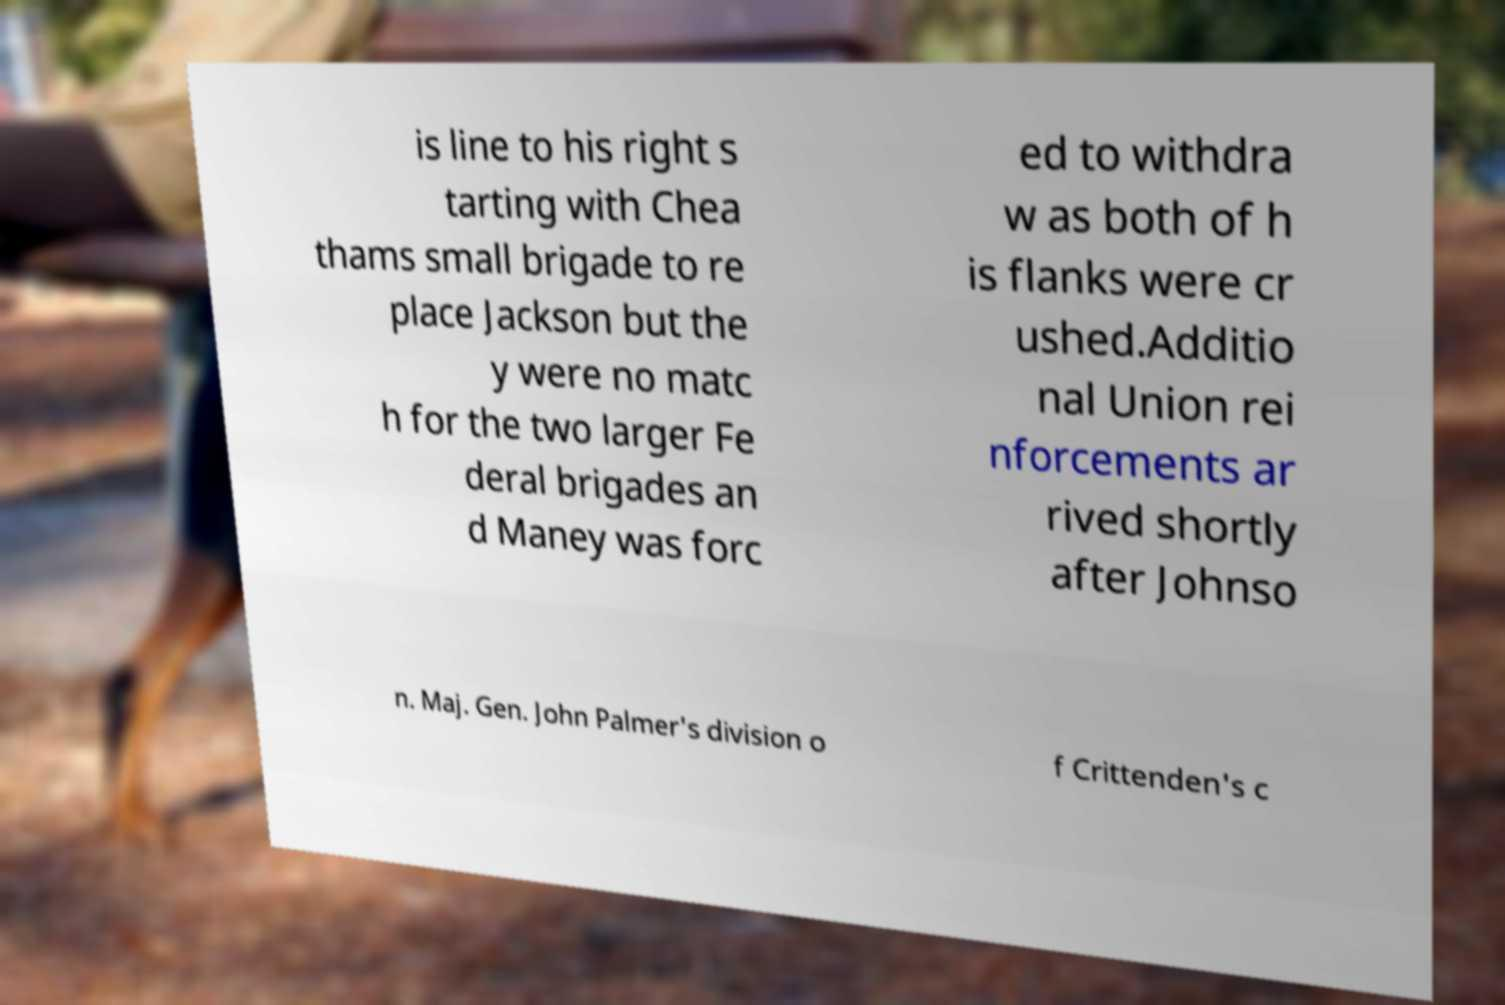Could you assist in decoding the text presented in this image and type it out clearly? is line to his right s tarting with Chea thams small brigade to re place Jackson but the y were no matc h for the two larger Fe deral brigades an d Maney was forc ed to withdra w as both of h is flanks were cr ushed.Additio nal Union rei nforcements ar rived shortly after Johnso n. Maj. Gen. John Palmer's division o f Crittenden's c 